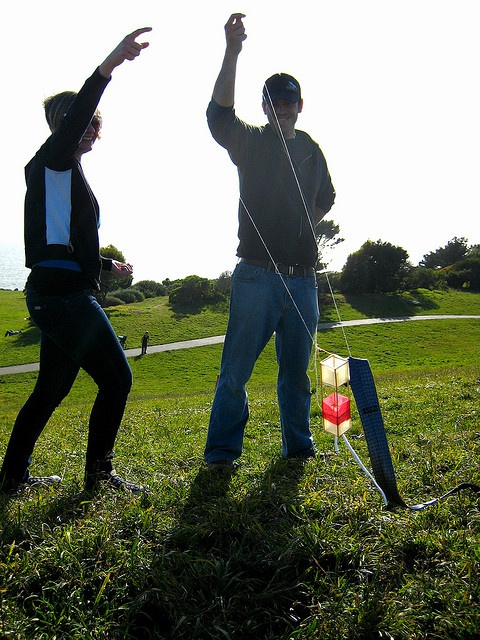Describe the objects in this image and their specific colors. I can see people in white, black, navy, and gray tones, people in white, black, gray, blue, and darkgreen tones, kite in white, black, navy, khaki, and beige tones, people in white, black, darkgreen, gray, and olive tones, and people in white, black, darkgreen, and navy tones in this image. 